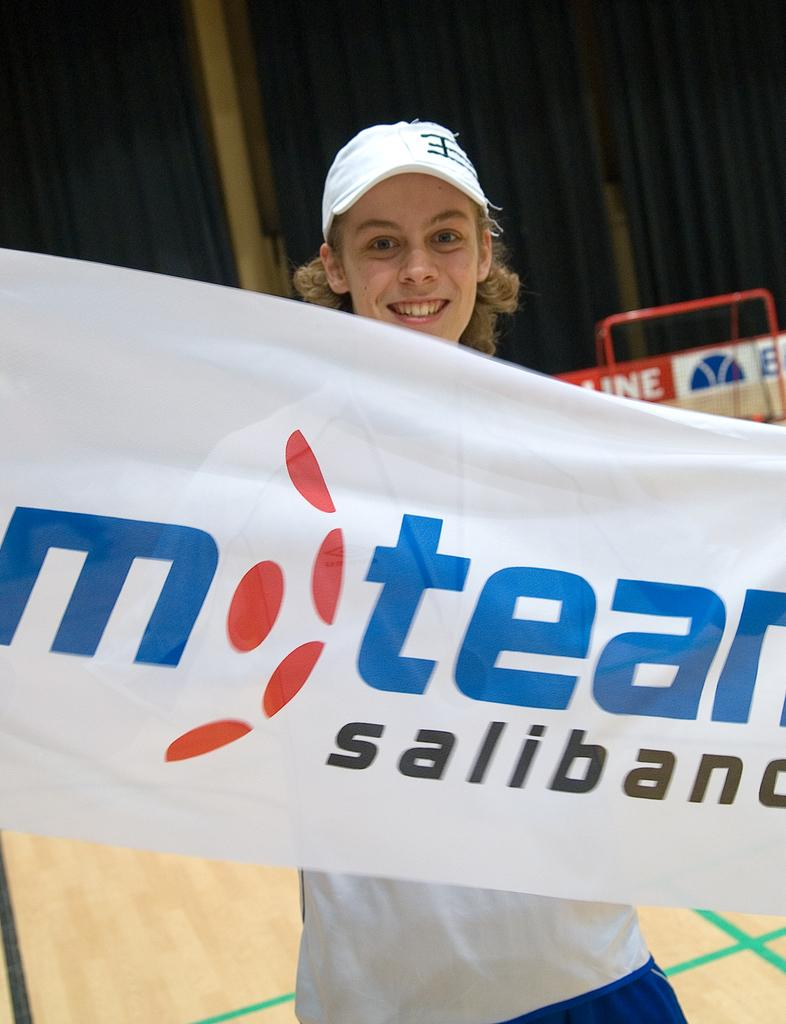What is the person in the image wearing on their head? The person in the image is wearing a cap. What is in front of the person in the image? There is a banner with writing in front of the person. What can be seen in the background of the image? There is a banner, a red color stand, and a curtain in the background of the image. What type of songs can be heard playing in the background of the image? There is no audio or music present in the image, so it is not possible to determine what songs might be heard. 